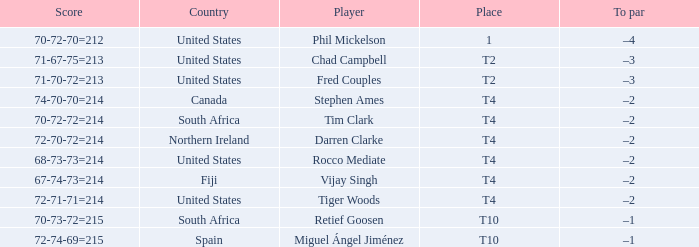What country does Rocco Mediate play for? United States. 